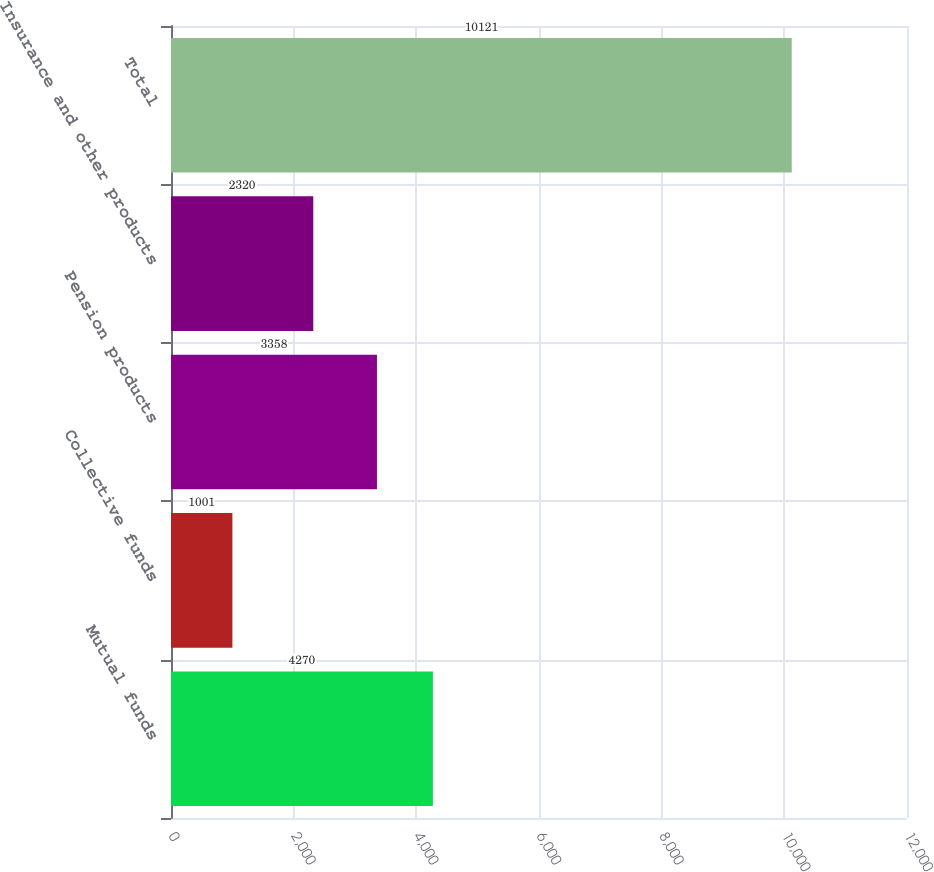Convert chart. <chart><loc_0><loc_0><loc_500><loc_500><bar_chart><fcel>Mutual funds<fcel>Collective funds<fcel>Pension products<fcel>Insurance and other products<fcel>Total<nl><fcel>4270<fcel>1001<fcel>3358<fcel>2320<fcel>10121<nl></chart> 